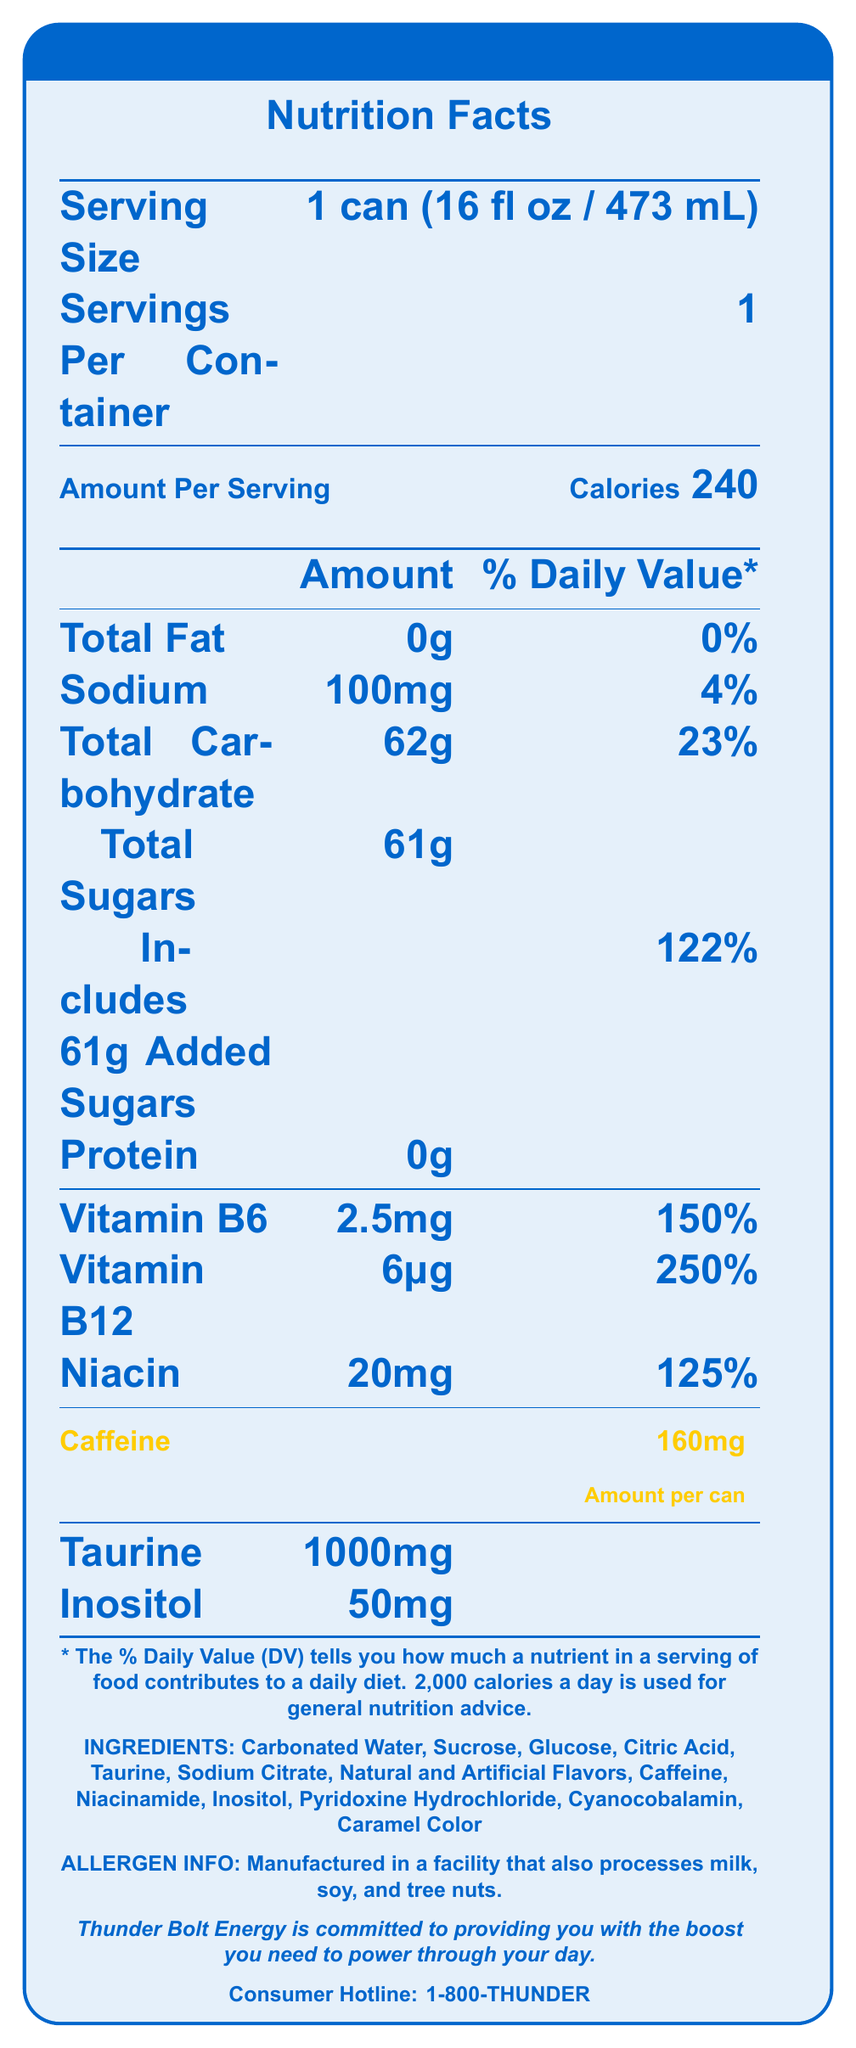what is the serving size for Thunder Bolt Energy? The serving size is clearly listed at the top of the Nutrition Facts section as "1 can (16 fl oz / 473 mL)".
Answer: 1 can (16 fl oz / 473 mL) how many calories are in one serving of Thunder Bolt Energy? The calories per serving are indicated right next to "Amount Per Serving" as 240.
Answer: 240 what is the caffeine content in a can of Thunder Bolt Energy? The caffeine content is prominently highlighted in yellow as "Caffeine 160mg", with a note "Amount per can".
Answer: 160mg how many grams of total sugars does Thunder Bolt Energy contain per serving? The total sugars amount is listed under Total Carbohydrate as 61g.
Answer: 61g what is the sodium content in Thunder Bolt Energy and its % Daily Value? The sodium content is listed as 100mg with a Daily Value percentage of 4%.
Answer: 100mg, 4% what are the main vitamins included in Thunder Bolt Energy and their % Daily Values? The vitamins and their percentages are listed under the nutrition breakdown: Vitamin B6 (2.5mg, 150%), Vitamin B12 (6μg, 250%), and Niacin (20mg, 125%).
Answer: Vitamin B6 (150%), Vitamin B12 (250%), Niacin (125%) which category does not have any amount listed for Thunder Bolt Energy? A. Total Fat B. Total Sugars C. Protein D. Sodium Under the amount per serving section, Protein is listed without an amount, indicating 0g.
Answer: C. Protein what is highlighted in the nutrition information to draw special attention? A. Total Carbohydrates B. Calories C. Caffeine D. Protein The caffeine content is highlighted in yellow, making it stand out from the rest of the nutritional information.
Answer: C. Caffeine does Thunder Bolt Energy contain any protein? The protein amount is listed as 0g in the nutrition facts.
Answer: No does the document provide any price information for the product? The document does not provide any price information. Pricing details were mentioned in the observer’s notes, but not visually present on the render.
Answer: No summarize the main idea of the document. The document is a nutrition facts label for Thunder Bolt Energy, highlighting nutritional values like calories, fats, vitamins, ingredients, and allergen information. It specifically emphasizes the caffeine content, using visual elements to draw attention to it.
Answer: Thunder Bolt Energy's Nutrition Facts Label provides detailed information on the beverage's serving size, calories, macronutrients, vitamins, and specific ingredients. The document highlights the caffeine content and includes allergen information. It also contains a brand statement and consumer hotline number. what allergens might be present in Thunder Bolt Energy? The allergen information states it is manufactured in a facility that also processes milk, soy, and tree nuts.
Answer: Manufactured in a facility that also processes milk, soy, and tree nuts. what added sugars percentage of Daily Value is in Thunder Bolt Energy? The included added sugars account for 61g, which is 122% Daily Value.
Answer: 122% describe the positional advantage for Thunder Bolt Energy on the shelf as noted in observer's notes. The observer's notes indicate that Thunder Bolt Energy is placed at eye-level in the center of the energy drink section, giving it a positional advantage.
Answer: Eye-level, center of energy drink section compare the caffeine content of Thunder Bolt Energy to its main competitors according to the observer's notes. The observer’s notes mention that Thunder Bolt Energy has a higher caffeine content compared to its main competitors.
Answer: Higher 